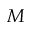Convert formula to latex. <formula><loc_0><loc_0><loc_500><loc_500>M</formula> 